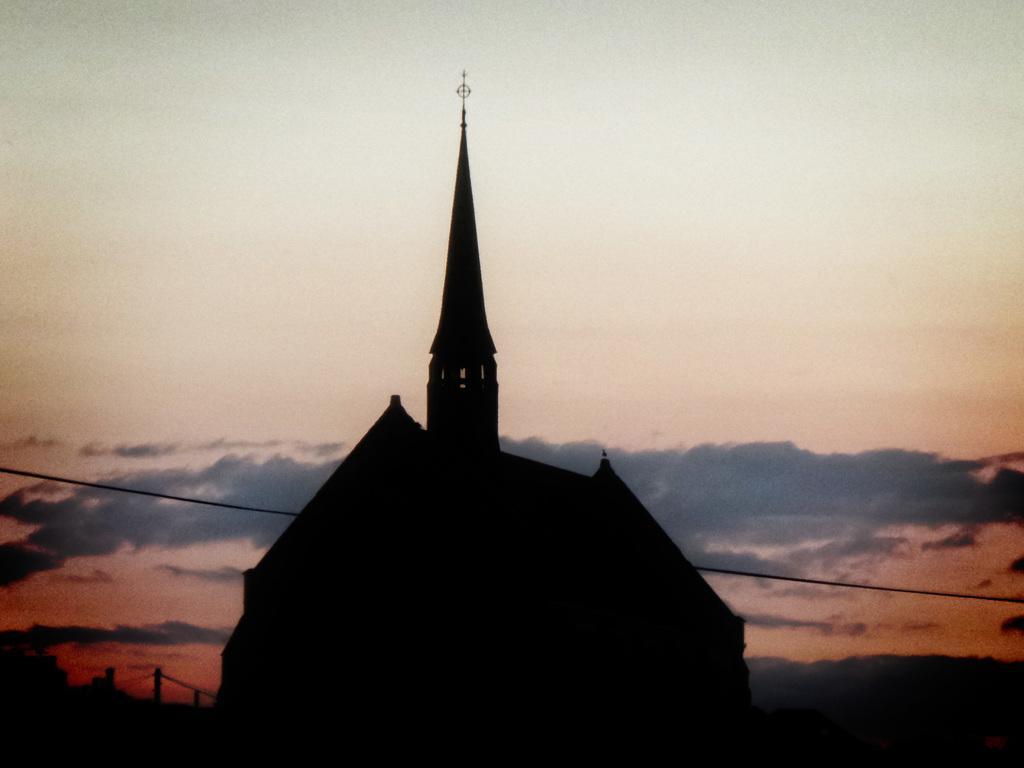How would you summarize this image in a sentence or two? In this picture we can see a house here, there is a wire here, in the background there is the sky. 